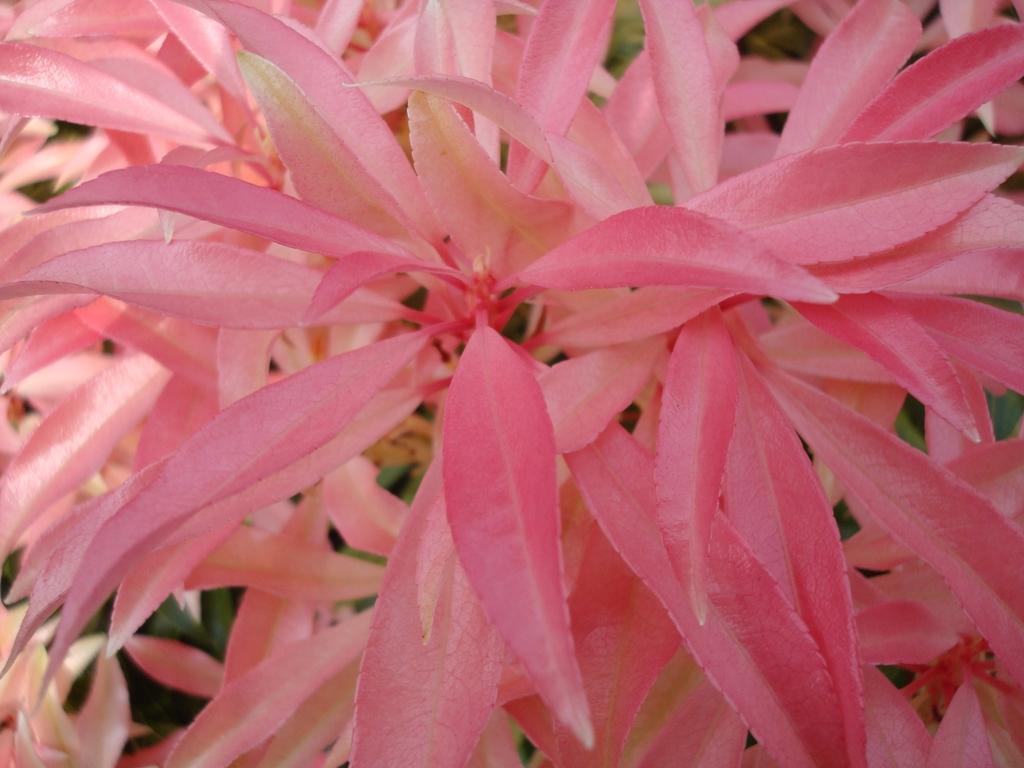Can you describe this image briefly? In the image we can see some plants. 